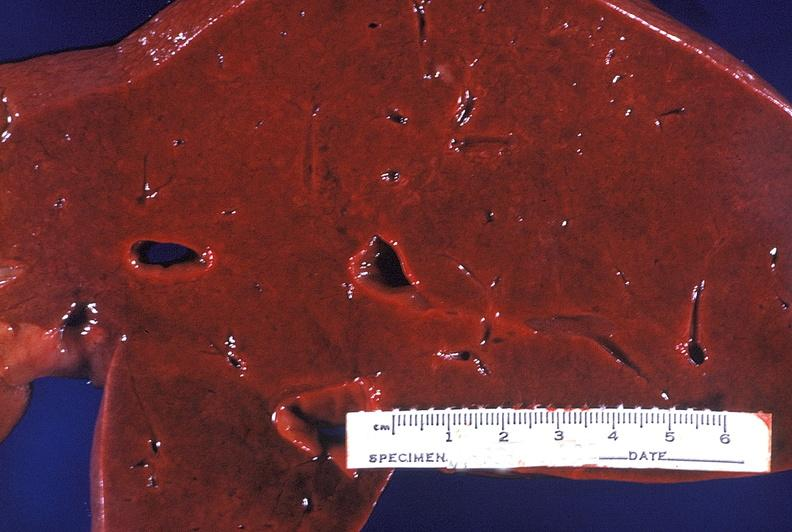what does this image show?
Answer the question using a single word or phrase. Normal liver 